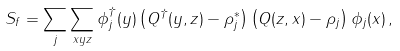<formula> <loc_0><loc_0><loc_500><loc_500>S _ { f } = \sum _ { j } \sum _ { x y z } \phi _ { j } ^ { \dagger } ( y ) \left ( Q ^ { \dagger } ( y , z ) - \rho _ { j } ^ { * } \right ) \left ( Q ( z , x ) - \rho _ { j } \right ) \phi _ { j } ( x ) \, ,</formula> 